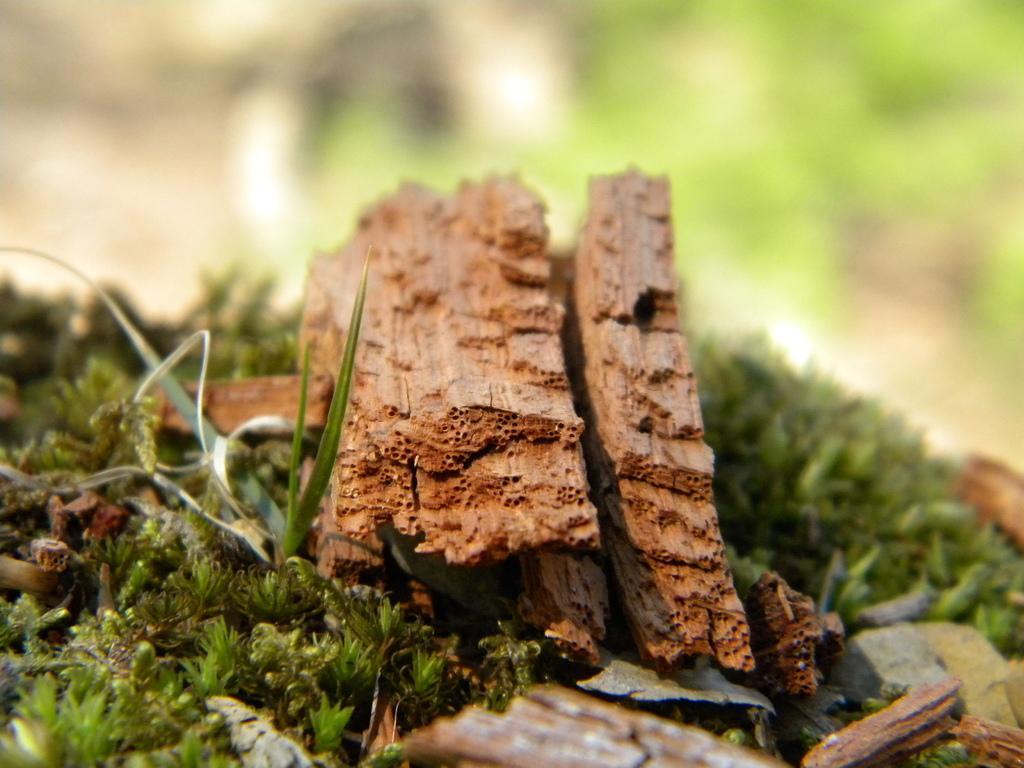How would you summarize this image in a sentence or two? In this picture there is a broken leg in the center of the image, on a grassland. 